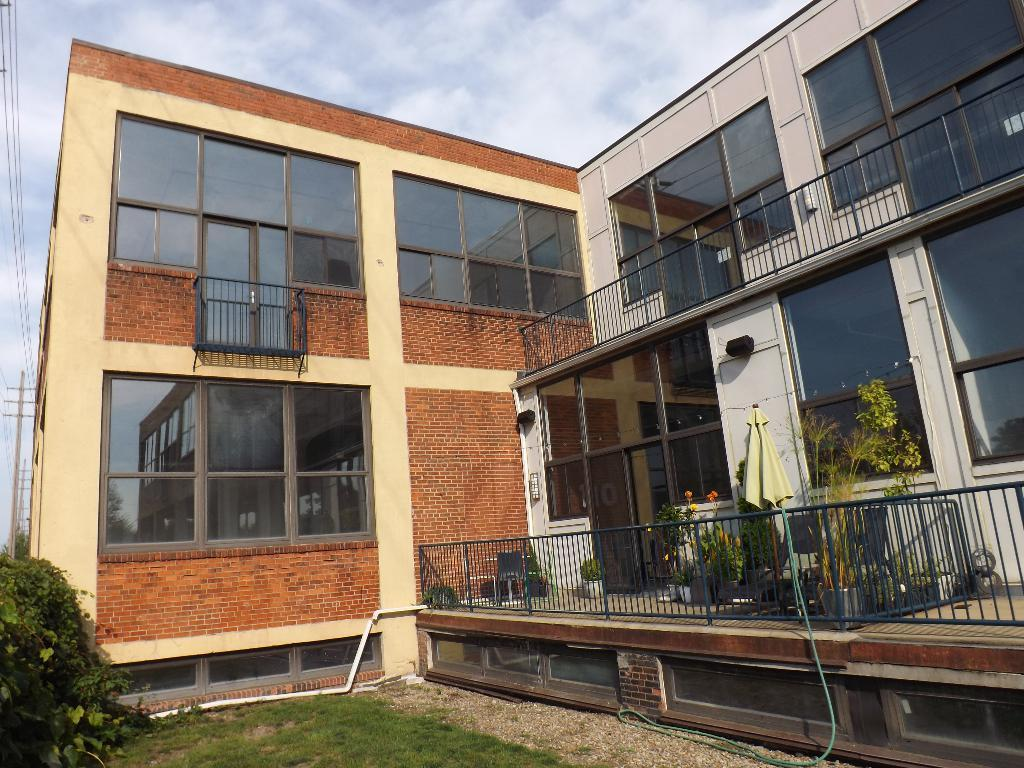What type of vegetation can be seen in the image? There is grass and shrubs in the image. What type of structure is present in the image? There is a steel railing, flower pots, an umbrella, a brick wall, glass windows, and poles in the image. What is visible in the background of the image? The sky is visible in the background of the image, with clouds present. Where is the lunchroom located in the image? There is no lunchroom present in the image. What book is the person reading in the image? There are no people or books visible in the image. 